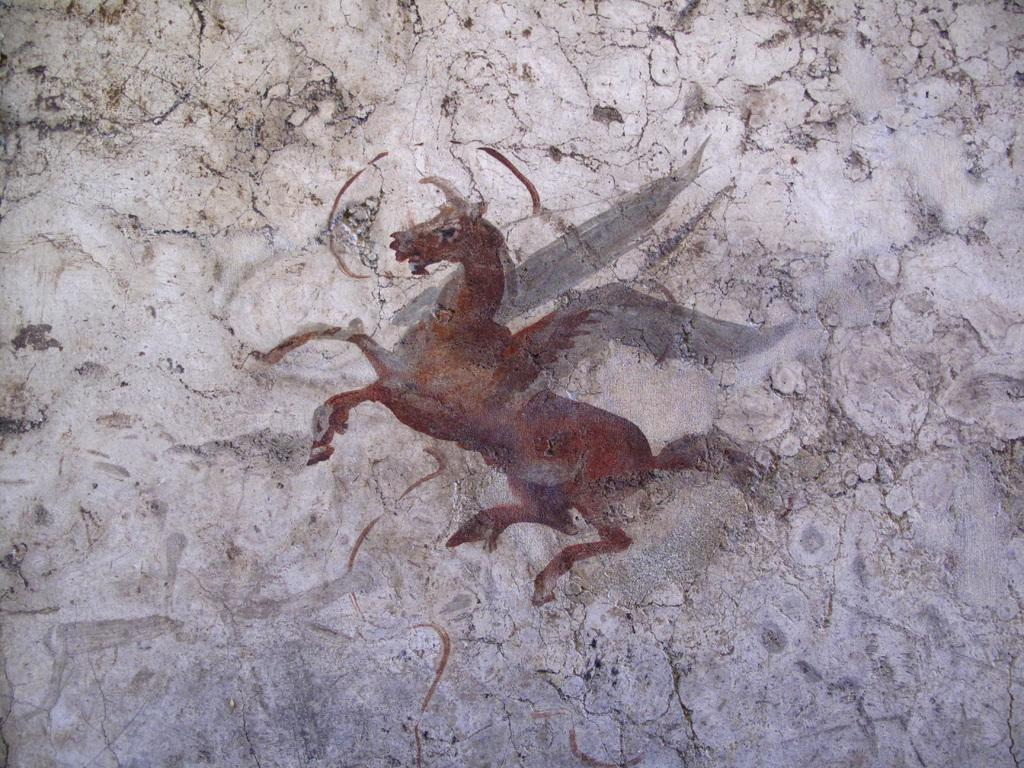What type of artwork is depicted in the image? The image is a painting. What subject matter is featured in the painting? There is a picture of a unicorn in the painting. Where is the unicorn located in the painting? The unicorn is on the wall in the painting. How does the river flow through the painting? There is no river present in the painting; it features a unicorn on a wall. 